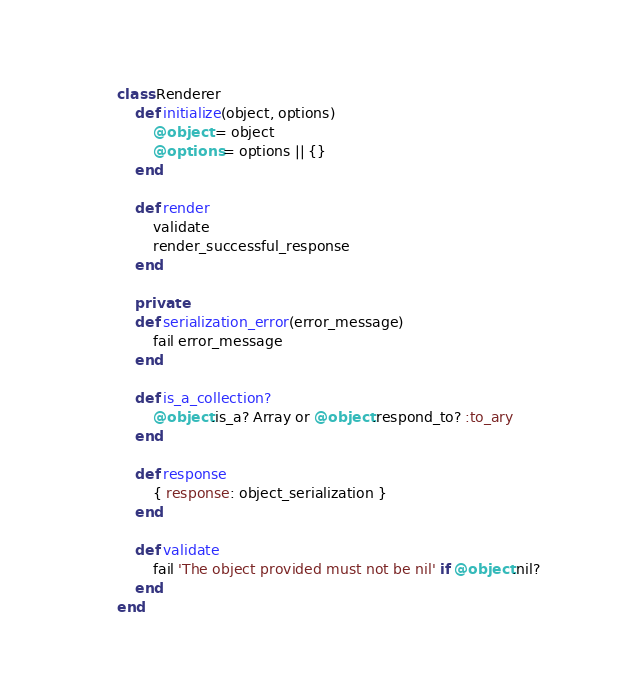Convert code to text. <code><loc_0><loc_0><loc_500><loc_500><_Ruby_>class Renderer
	def initialize(object, options)
		@object = object
		@options = options || {}
	end

	def render
		validate
		render_successful_response
	end

	private
	def serialization_error(error_message)
		fail error_message
	end

	def is_a_collection?
		@object.is_a? Array or @object.respond_to? :to_ary
	end

	def response
		{ response: object_serialization }
	end

	def validate
		fail 'The object provided must not be nil' if @object.nil?
	end
end</code> 